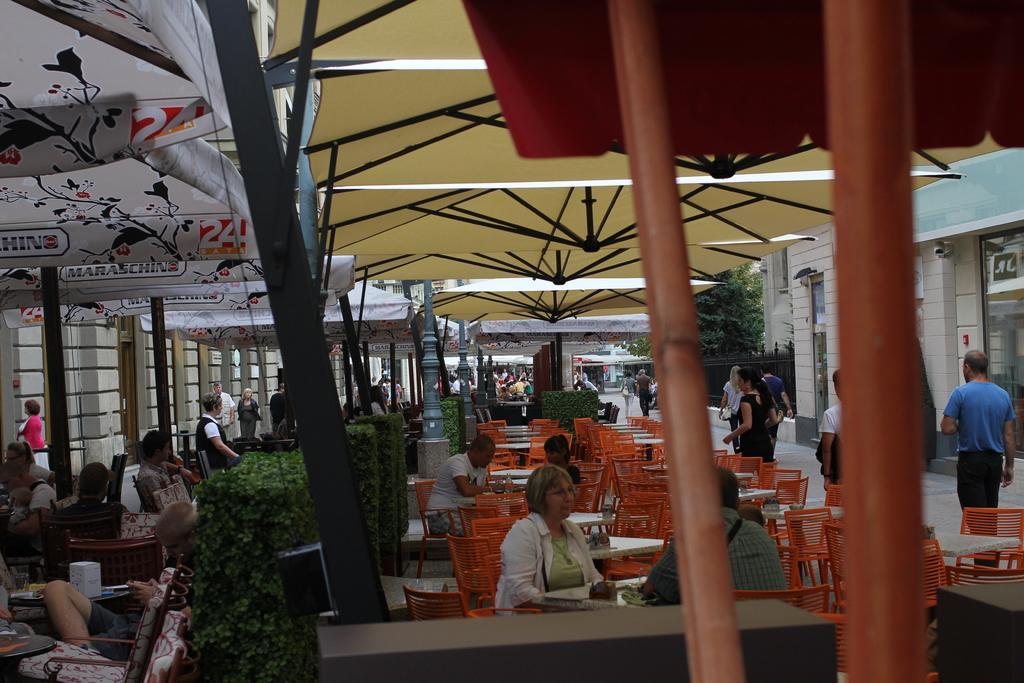Describe this image in one or two sentences. In this image we can see some people and among them few people are walking and few people are sitting on chairs. We can see some chairs and tables under the tents and the place looks like a restaurant and we can see some plants and trees and there are some buildings. 